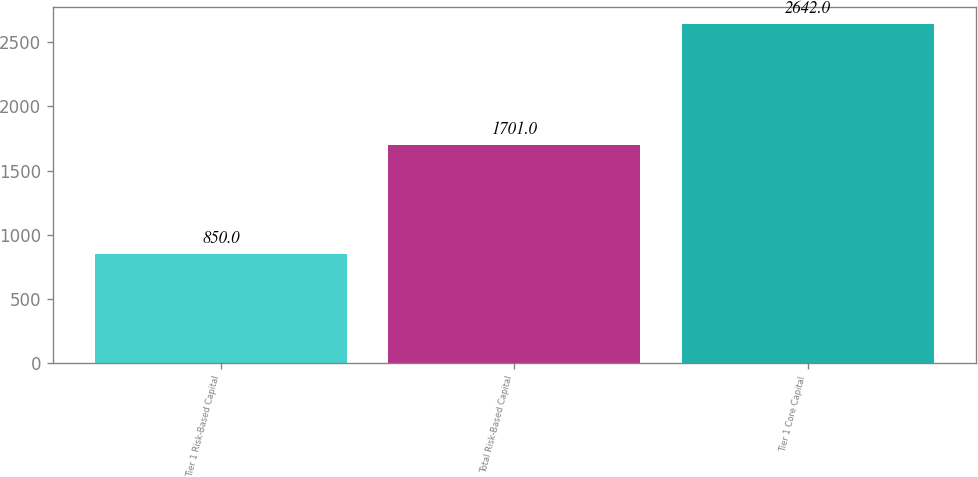Convert chart. <chart><loc_0><loc_0><loc_500><loc_500><bar_chart><fcel>Tier 1 Risk-Based Capital<fcel>Total Risk-Based Capital<fcel>Tier 1 Core Capital<nl><fcel>850<fcel>1701<fcel>2642<nl></chart> 